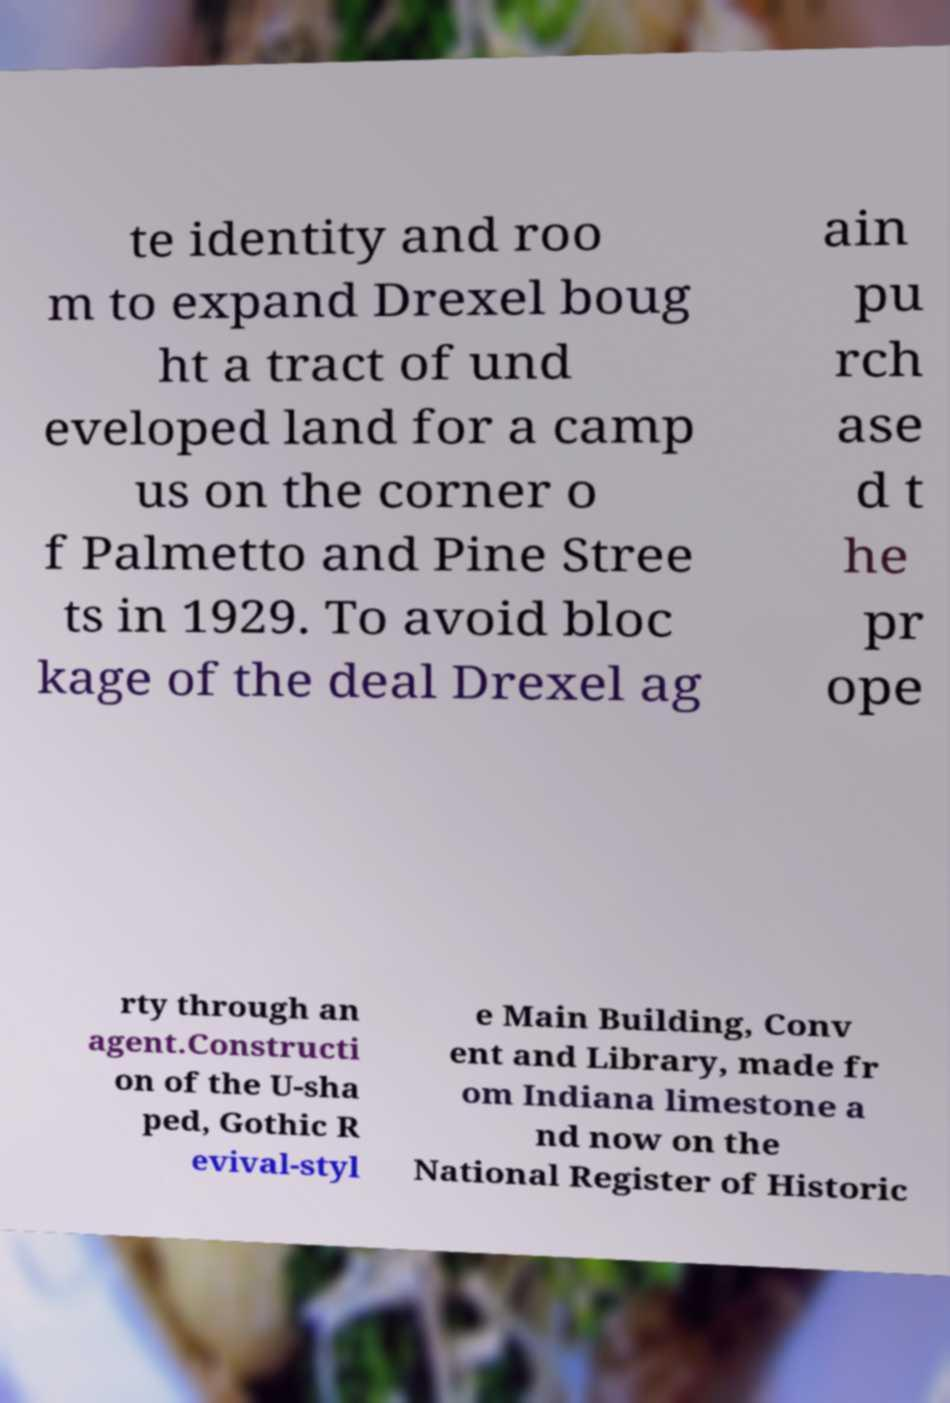I need the written content from this picture converted into text. Can you do that? te identity and roo m to expand Drexel boug ht a tract of und eveloped land for a camp us on the corner o f Palmetto and Pine Stree ts in 1929. To avoid bloc kage of the deal Drexel ag ain pu rch ase d t he pr ope rty through an agent.Constructi on of the U-sha ped, Gothic R evival-styl e Main Building, Conv ent and Library, made fr om Indiana limestone a nd now on the National Register of Historic 